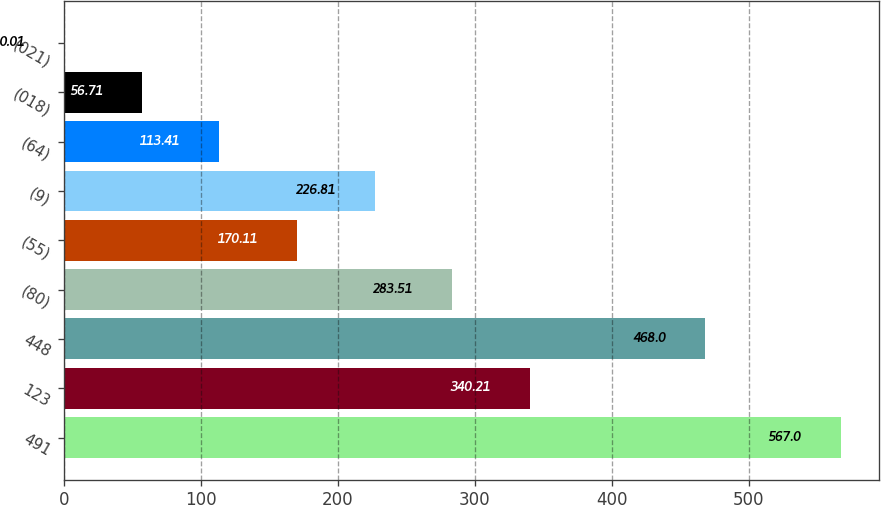<chart> <loc_0><loc_0><loc_500><loc_500><bar_chart><fcel>491<fcel>123<fcel>448<fcel>(80)<fcel>(55)<fcel>(9)<fcel>(64)<fcel>(018)<fcel>(021)<nl><fcel>567<fcel>340.21<fcel>468<fcel>283.51<fcel>170.11<fcel>226.81<fcel>113.41<fcel>56.71<fcel>0.01<nl></chart> 